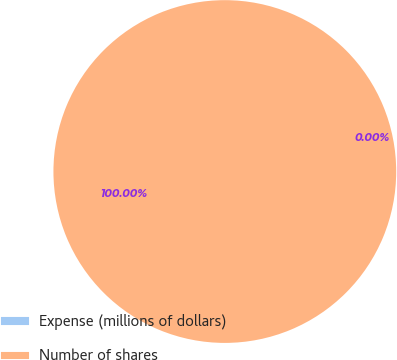<chart> <loc_0><loc_0><loc_500><loc_500><pie_chart><fcel>Expense (millions of dollars)<fcel>Number of shares<nl><fcel>0.0%<fcel>100.0%<nl></chart> 